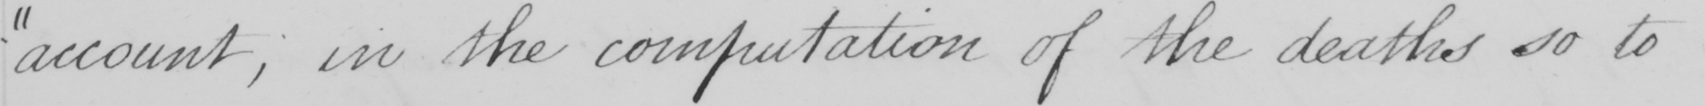What is written in this line of handwriting? " account , in the computation of the deaths so to 